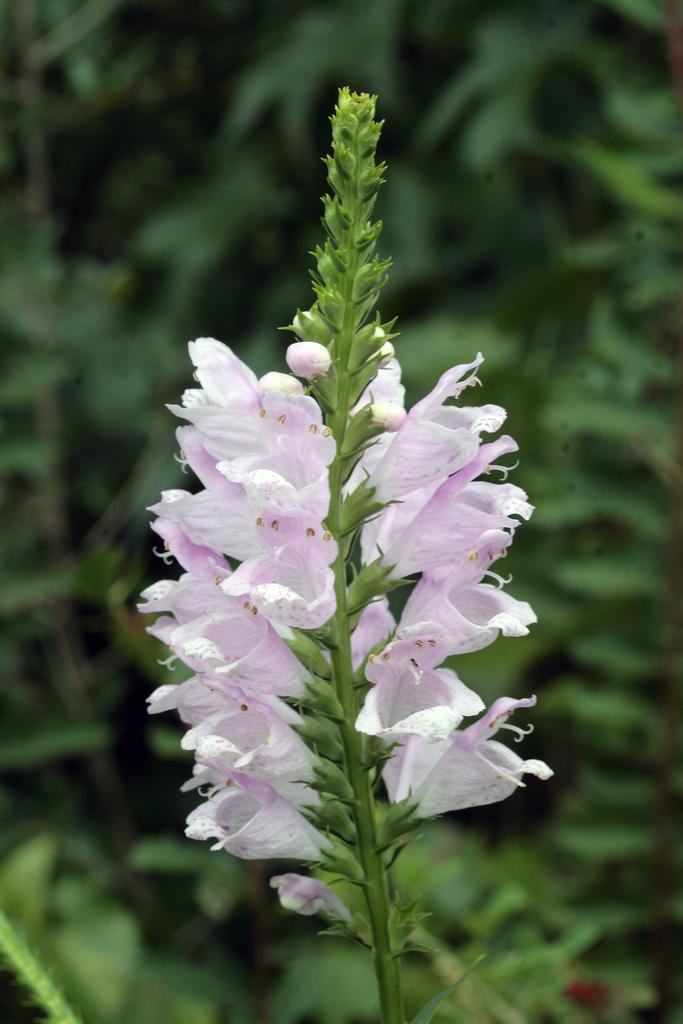What is the main subject in the center of the image? There is a flower plant in the center of the image. What else can be seen in the background of the image? There are other plants in the background of the image. How many pages are visible in the image? There are no pages present in the image; it features a flower plant and other plants. What type of shoes can be seen on the flower plant in the image? There are no shoes present in the image; it features a flower plant and other plants. 